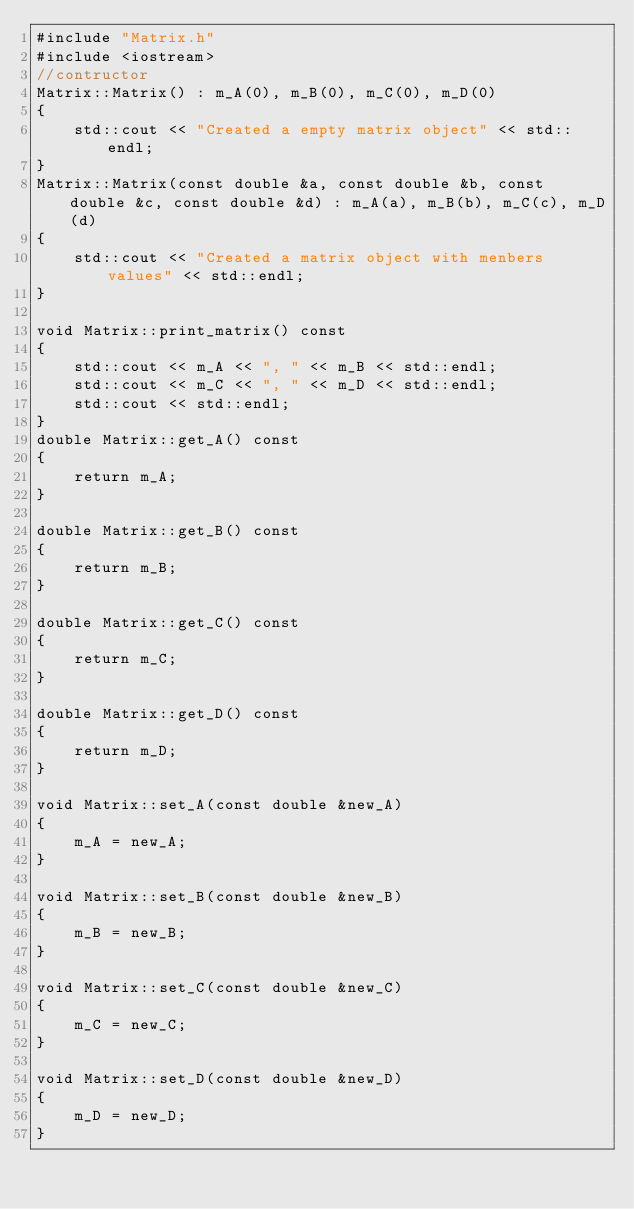<code> <loc_0><loc_0><loc_500><loc_500><_C++_>#include "Matrix.h"
#include <iostream>
//contructor
Matrix::Matrix() : m_A(0), m_B(0), m_C(0), m_D(0)
{
    std::cout << "Created a empty matrix object" << std::endl;
}
Matrix::Matrix(const double &a, const double &b, const double &c, const double &d) : m_A(a), m_B(b), m_C(c), m_D(d)
{
    std::cout << "Created a matrix object with menbers values" << std::endl;
}

void Matrix::print_matrix() const
{
    std::cout << m_A << ", " << m_B << std::endl;
    std::cout << m_C << ", " << m_D << std::endl;
    std::cout << std::endl;
}
double Matrix::get_A() const
{
    return m_A;
}

double Matrix::get_B() const
{
    return m_B;
}

double Matrix::get_C() const
{
    return m_C;
}

double Matrix::get_D() const
{
    return m_D;
}

void Matrix::set_A(const double &new_A)
{
    m_A = new_A;
}

void Matrix::set_B(const double &new_B)
{
    m_B = new_B;
}

void Matrix::set_C(const double &new_C)
{
    m_C = new_C;
}

void Matrix::set_D(const double &new_D)
{
    m_D = new_D;
}
</code> 